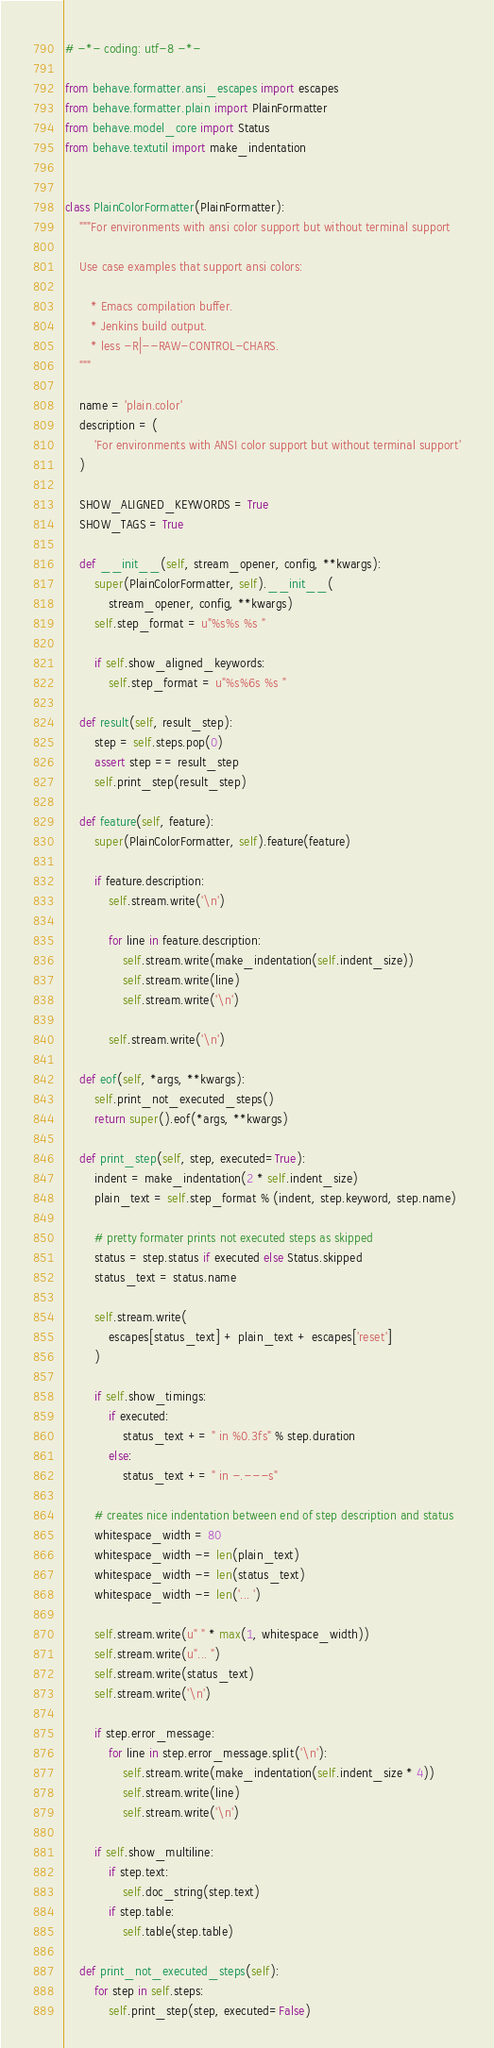<code> <loc_0><loc_0><loc_500><loc_500><_Python_># -*- coding: utf-8 -*-

from behave.formatter.ansi_escapes import escapes
from behave.formatter.plain import PlainFormatter
from behave.model_core import Status
from behave.textutil import make_indentation


class PlainColorFormatter(PlainFormatter):
    """For environments with ansi color support but without terminal support

    Use case examples that support ansi colors:

       * Emacs compilation buffer.
       * Jenkins build output.
       * less -R|--RAW-CONTROL-CHARS.
    """

    name = 'plain.color'
    description = (
        'For environments with ANSI color support but without terminal support'
    )

    SHOW_ALIGNED_KEYWORDS = True
    SHOW_TAGS = True

    def __init__(self, stream_opener, config, **kwargs):
        super(PlainColorFormatter, self).__init__(
            stream_opener, config, **kwargs)
        self.step_format = u"%s%s %s "

        if self.show_aligned_keywords:
            self.step_format = u"%s%6s %s "

    def result(self, result_step):
        step = self.steps.pop(0)
        assert step == result_step
        self.print_step(result_step)

    def feature(self, feature):
        super(PlainColorFormatter, self).feature(feature)

        if feature.description:
            self.stream.write('\n')

            for line in feature.description:
                self.stream.write(make_indentation(self.indent_size))
                self.stream.write(line)
                self.stream.write('\n')

            self.stream.write('\n')

    def eof(self, *args, **kwargs):
        self.print_not_executed_steps()
        return super().eof(*args, **kwargs)

    def print_step(self, step, executed=True):
        indent = make_indentation(2 * self.indent_size)
        plain_text = self.step_format % (indent, step.keyword, step.name)

        # pretty formater prints not executed steps as skipped
        status = step.status if executed else Status.skipped
        status_text = status.name

        self.stream.write(
            escapes[status_text] + plain_text + escapes['reset']
        )

        if self.show_timings:
            if executed:
                status_text += " in %0.3fs" % step.duration
            else:
                status_text += " in -.---s"

        # creates nice indentation between end of step description and status
        whitespace_width = 80
        whitespace_width -= len(plain_text)
        whitespace_width -= len(status_text)
        whitespace_width -= len('... ')

        self.stream.write(u" " * max(1, whitespace_width))
        self.stream.write(u"... ")
        self.stream.write(status_text)
        self.stream.write('\n')

        if step.error_message:
            for line in step.error_message.split('\n'):
                self.stream.write(make_indentation(self.indent_size * 4))
                self.stream.write(line)
                self.stream.write('\n')

        if self.show_multiline:
            if step.text:
                self.doc_string(step.text)
            if step.table:
                self.table(step.table)

    def print_not_executed_steps(self):
        for step in self.steps:
            self.print_step(step, executed=False)
</code> 